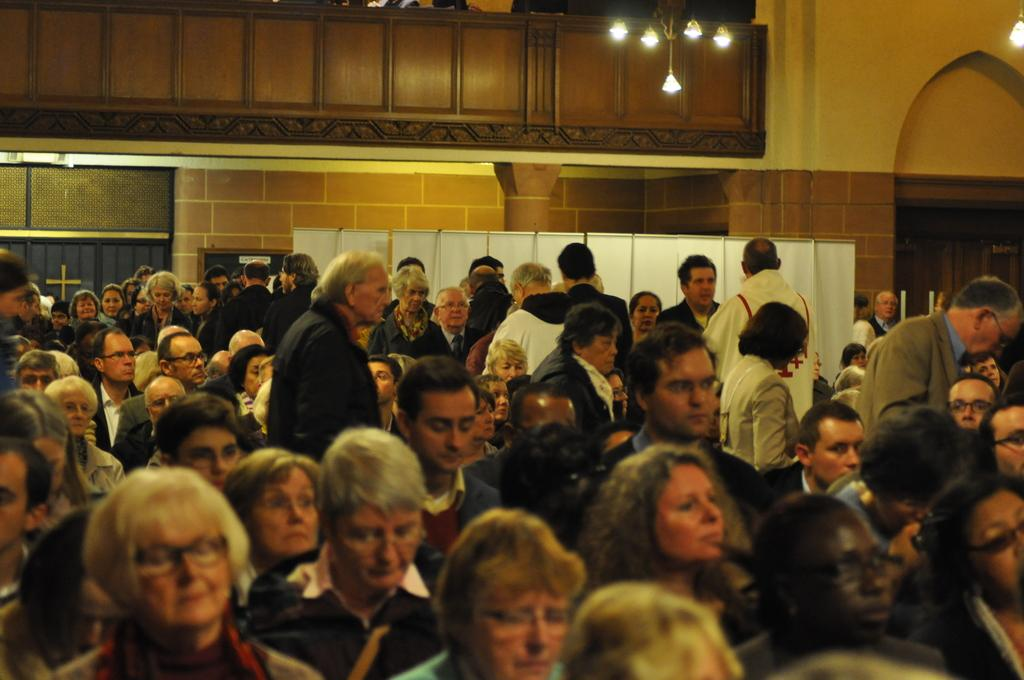How many people are in the hall in the image? There are many persons in the hall in the image. What can be seen in the background of the image? There is a wall in the background of the image. What is on the wall in the image? There is a banner on the wall in the image. What is visible at the top of the image? There are lights at the top of the image. What type of animal is being held in a jail cell in the image? There is no jail or animal present in the image. What day of the week is depicted in the image? The image does not show a specific day of the week. 